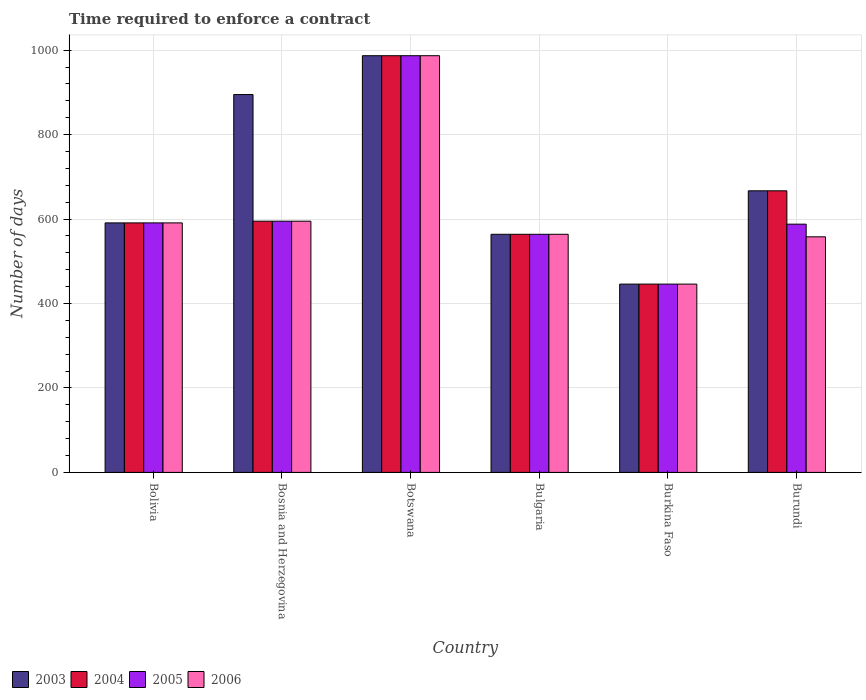How many different coloured bars are there?
Your response must be concise. 4. Are the number of bars per tick equal to the number of legend labels?
Provide a short and direct response. Yes. Are the number of bars on each tick of the X-axis equal?
Your response must be concise. Yes. How many bars are there on the 6th tick from the left?
Provide a succinct answer. 4. What is the number of days required to enforce a contract in 2005 in Botswana?
Keep it short and to the point. 987. Across all countries, what is the maximum number of days required to enforce a contract in 2004?
Your answer should be very brief. 987. Across all countries, what is the minimum number of days required to enforce a contract in 2005?
Provide a succinct answer. 446. In which country was the number of days required to enforce a contract in 2006 maximum?
Offer a terse response. Botswana. In which country was the number of days required to enforce a contract in 2006 minimum?
Provide a short and direct response. Burkina Faso. What is the total number of days required to enforce a contract in 2006 in the graph?
Keep it short and to the point. 3741. What is the difference between the number of days required to enforce a contract in 2005 in Bosnia and Herzegovina and that in Burkina Faso?
Offer a terse response. 149. What is the difference between the number of days required to enforce a contract in 2004 in Botswana and the number of days required to enforce a contract in 2003 in Bolivia?
Keep it short and to the point. 396. What is the average number of days required to enforce a contract in 2006 per country?
Your answer should be compact. 623.5. What is the ratio of the number of days required to enforce a contract in 2005 in Bolivia to that in Botswana?
Your answer should be compact. 0.6. Is the difference between the number of days required to enforce a contract in 2004 in Burkina Faso and Burundi greater than the difference between the number of days required to enforce a contract in 2003 in Burkina Faso and Burundi?
Offer a very short reply. No. What is the difference between the highest and the second highest number of days required to enforce a contract in 2005?
Your response must be concise. -392. What is the difference between the highest and the lowest number of days required to enforce a contract in 2004?
Your answer should be very brief. 541. In how many countries, is the number of days required to enforce a contract in 2004 greater than the average number of days required to enforce a contract in 2004 taken over all countries?
Your answer should be very brief. 2. Is it the case that in every country, the sum of the number of days required to enforce a contract in 2005 and number of days required to enforce a contract in 2004 is greater than the sum of number of days required to enforce a contract in 2006 and number of days required to enforce a contract in 2003?
Your answer should be compact. No. Is it the case that in every country, the sum of the number of days required to enforce a contract in 2004 and number of days required to enforce a contract in 2005 is greater than the number of days required to enforce a contract in 2006?
Your answer should be very brief. Yes. How many countries are there in the graph?
Offer a terse response. 6. Where does the legend appear in the graph?
Your response must be concise. Bottom left. How many legend labels are there?
Give a very brief answer. 4. What is the title of the graph?
Provide a short and direct response. Time required to enforce a contract. Does "2009" appear as one of the legend labels in the graph?
Offer a terse response. No. What is the label or title of the Y-axis?
Ensure brevity in your answer.  Number of days. What is the Number of days in 2003 in Bolivia?
Offer a very short reply. 591. What is the Number of days in 2004 in Bolivia?
Your response must be concise. 591. What is the Number of days of 2005 in Bolivia?
Provide a succinct answer. 591. What is the Number of days of 2006 in Bolivia?
Give a very brief answer. 591. What is the Number of days in 2003 in Bosnia and Herzegovina?
Your response must be concise. 895. What is the Number of days of 2004 in Bosnia and Herzegovina?
Keep it short and to the point. 595. What is the Number of days of 2005 in Bosnia and Herzegovina?
Provide a succinct answer. 595. What is the Number of days of 2006 in Bosnia and Herzegovina?
Offer a terse response. 595. What is the Number of days in 2003 in Botswana?
Ensure brevity in your answer.  987. What is the Number of days in 2004 in Botswana?
Keep it short and to the point. 987. What is the Number of days of 2005 in Botswana?
Provide a succinct answer. 987. What is the Number of days in 2006 in Botswana?
Make the answer very short. 987. What is the Number of days of 2003 in Bulgaria?
Offer a terse response. 564. What is the Number of days of 2004 in Bulgaria?
Offer a terse response. 564. What is the Number of days of 2005 in Bulgaria?
Provide a short and direct response. 564. What is the Number of days in 2006 in Bulgaria?
Your answer should be very brief. 564. What is the Number of days of 2003 in Burkina Faso?
Your response must be concise. 446. What is the Number of days in 2004 in Burkina Faso?
Provide a succinct answer. 446. What is the Number of days of 2005 in Burkina Faso?
Provide a short and direct response. 446. What is the Number of days in 2006 in Burkina Faso?
Offer a terse response. 446. What is the Number of days in 2003 in Burundi?
Make the answer very short. 667. What is the Number of days of 2004 in Burundi?
Your response must be concise. 667. What is the Number of days of 2005 in Burundi?
Your answer should be very brief. 588. What is the Number of days of 2006 in Burundi?
Keep it short and to the point. 558. Across all countries, what is the maximum Number of days in 2003?
Ensure brevity in your answer.  987. Across all countries, what is the maximum Number of days in 2004?
Your answer should be very brief. 987. Across all countries, what is the maximum Number of days of 2005?
Offer a terse response. 987. Across all countries, what is the maximum Number of days of 2006?
Your answer should be compact. 987. Across all countries, what is the minimum Number of days of 2003?
Offer a very short reply. 446. Across all countries, what is the minimum Number of days in 2004?
Your answer should be very brief. 446. Across all countries, what is the minimum Number of days of 2005?
Offer a terse response. 446. Across all countries, what is the minimum Number of days in 2006?
Offer a terse response. 446. What is the total Number of days of 2003 in the graph?
Ensure brevity in your answer.  4150. What is the total Number of days in 2004 in the graph?
Ensure brevity in your answer.  3850. What is the total Number of days in 2005 in the graph?
Give a very brief answer. 3771. What is the total Number of days in 2006 in the graph?
Your response must be concise. 3741. What is the difference between the Number of days of 2003 in Bolivia and that in Bosnia and Herzegovina?
Keep it short and to the point. -304. What is the difference between the Number of days in 2003 in Bolivia and that in Botswana?
Keep it short and to the point. -396. What is the difference between the Number of days of 2004 in Bolivia and that in Botswana?
Your response must be concise. -396. What is the difference between the Number of days of 2005 in Bolivia and that in Botswana?
Offer a terse response. -396. What is the difference between the Number of days of 2006 in Bolivia and that in Botswana?
Your response must be concise. -396. What is the difference between the Number of days of 2003 in Bolivia and that in Bulgaria?
Offer a terse response. 27. What is the difference between the Number of days of 2005 in Bolivia and that in Bulgaria?
Your response must be concise. 27. What is the difference between the Number of days of 2006 in Bolivia and that in Bulgaria?
Keep it short and to the point. 27. What is the difference between the Number of days in 2003 in Bolivia and that in Burkina Faso?
Give a very brief answer. 145. What is the difference between the Number of days of 2004 in Bolivia and that in Burkina Faso?
Provide a short and direct response. 145. What is the difference between the Number of days in 2005 in Bolivia and that in Burkina Faso?
Give a very brief answer. 145. What is the difference between the Number of days in 2006 in Bolivia and that in Burkina Faso?
Give a very brief answer. 145. What is the difference between the Number of days in 2003 in Bolivia and that in Burundi?
Your response must be concise. -76. What is the difference between the Number of days in 2004 in Bolivia and that in Burundi?
Provide a short and direct response. -76. What is the difference between the Number of days of 2003 in Bosnia and Herzegovina and that in Botswana?
Give a very brief answer. -92. What is the difference between the Number of days of 2004 in Bosnia and Herzegovina and that in Botswana?
Offer a very short reply. -392. What is the difference between the Number of days in 2005 in Bosnia and Herzegovina and that in Botswana?
Your response must be concise. -392. What is the difference between the Number of days of 2006 in Bosnia and Herzegovina and that in Botswana?
Your response must be concise. -392. What is the difference between the Number of days in 2003 in Bosnia and Herzegovina and that in Bulgaria?
Make the answer very short. 331. What is the difference between the Number of days of 2004 in Bosnia and Herzegovina and that in Bulgaria?
Offer a terse response. 31. What is the difference between the Number of days of 2006 in Bosnia and Herzegovina and that in Bulgaria?
Keep it short and to the point. 31. What is the difference between the Number of days of 2003 in Bosnia and Herzegovina and that in Burkina Faso?
Provide a succinct answer. 449. What is the difference between the Number of days of 2004 in Bosnia and Herzegovina and that in Burkina Faso?
Keep it short and to the point. 149. What is the difference between the Number of days of 2005 in Bosnia and Herzegovina and that in Burkina Faso?
Offer a very short reply. 149. What is the difference between the Number of days of 2006 in Bosnia and Herzegovina and that in Burkina Faso?
Your answer should be very brief. 149. What is the difference between the Number of days in 2003 in Bosnia and Herzegovina and that in Burundi?
Your answer should be very brief. 228. What is the difference between the Number of days in 2004 in Bosnia and Herzegovina and that in Burundi?
Your answer should be very brief. -72. What is the difference between the Number of days of 2005 in Bosnia and Herzegovina and that in Burundi?
Make the answer very short. 7. What is the difference between the Number of days of 2006 in Bosnia and Herzegovina and that in Burundi?
Keep it short and to the point. 37. What is the difference between the Number of days of 2003 in Botswana and that in Bulgaria?
Keep it short and to the point. 423. What is the difference between the Number of days in 2004 in Botswana and that in Bulgaria?
Provide a short and direct response. 423. What is the difference between the Number of days in 2005 in Botswana and that in Bulgaria?
Make the answer very short. 423. What is the difference between the Number of days of 2006 in Botswana and that in Bulgaria?
Your answer should be very brief. 423. What is the difference between the Number of days of 2003 in Botswana and that in Burkina Faso?
Offer a very short reply. 541. What is the difference between the Number of days in 2004 in Botswana and that in Burkina Faso?
Offer a very short reply. 541. What is the difference between the Number of days of 2005 in Botswana and that in Burkina Faso?
Offer a very short reply. 541. What is the difference between the Number of days of 2006 in Botswana and that in Burkina Faso?
Keep it short and to the point. 541. What is the difference between the Number of days of 2003 in Botswana and that in Burundi?
Make the answer very short. 320. What is the difference between the Number of days in 2004 in Botswana and that in Burundi?
Offer a terse response. 320. What is the difference between the Number of days of 2005 in Botswana and that in Burundi?
Ensure brevity in your answer.  399. What is the difference between the Number of days in 2006 in Botswana and that in Burundi?
Keep it short and to the point. 429. What is the difference between the Number of days of 2003 in Bulgaria and that in Burkina Faso?
Give a very brief answer. 118. What is the difference between the Number of days in 2004 in Bulgaria and that in Burkina Faso?
Your answer should be very brief. 118. What is the difference between the Number of days in 2005 in Bulgaria and that in Burkina Faso?
Give a very brief answer. 118. What is the difference between the Number of days in 2006 in Bulgaria and that in Burkina Faso?
Provide a short and direct response. 118. What is the difference between the Number of days of 2003 in Bulgaria and that in Burundi?
Make the answer very short. -103. What is the difference between the Number of days of 2004 in Bulgaria and that in Burundi?
Your answer should be compact. -103. What is the difference between the Number of days in 2005 in Bulgaria and that in Burundi?
Your response must be concise. -24. What is the difference between the Number of days in 2006 in Bulgaria and that in Burundi?
Offer a very short reply. 6. What is the difference between the Number of days of 2003 in Burkina Faso and that in Burundi?
Ensure brevity in your answer.  -221. What is the difference between the Number of days of 2004 in Burkina Faso and that in Burundi?
Provide a short and direct response. -221. What is the difference between the Number of days in 2005 in Burkina Faso and that in Burundi?
Offer a very short reply. -142. What is the difference between the Number of days of 2006 in Burkina Faso and that in Burundi?
Give a very brief answer. -112. What is the difference between the Number of days of 2003 in Bolivia and the Number of days of 2004 in Bosnia and Herzegovina?
Provide a succinct answer. -4. What is the difference between the Number of days in 2003 in Bolivia and the Number of days in 2006 in Bosnia and Herzegovina?
Make the answer very short. -4. What is the difference between the Number of days in 2004 in Bolivia and the Number of days in 2005 in Bosnia and Herzegovina?
Your response must be concise. -4. What is the difference between the Number of days in 2004 in Bolivia and the Number of days in 2006 in Bosnia and Herzegovina?
Your answer should be compact. -4. What is the difference between the Number of days of 2003 in Bolivia and the Number of days of 2004 in Botswana?
Offer a terse response. -396. What is the difference between the Number of days in 2003 in Bolivia and the Number of days in 2005 in Botswana?
Ensure brevity in your answer.  -396. What is the difference between the Number of days in 2003 in Bolivia and the Number of days in 2006 in Botswana?
Provide a short and direct response. -396. What is the difference between the Number of days in 2004 in Bolivia and the Number of days in 2005 in Botswana?
Keep it short and to the point. -396. What is the difference between the Number of days of 2004 in Bolivia and the Number of days of 2006 in Botswana?
Make the answer very short. -396. What is the difference between the Number of days in 2005 in Bolivia and the Number of days in 2006 in Botswana?
Offer a terse response. -396. What is the difference between the Number of days in 2003 in Bolivia and the Number of days in 2005 in Bulgaria?
Provide a succinct answer. 27. What is the difference between the Number of days of 2003 in Bolivia and the Number of days of 2006 in Bulgaria?
Keep it short and to the point. 27. What is the difference between the Number of days in 2004 in Bolivia and the Number of days in 2006 in Bulgaria?
Ensure brevity in your answer.  27. What is the difference between the Number of days in 2003 in Bolivia and the Number of days in 2004 in Burkina Faso?
Provide a succinct answer. 145. What is the difference between the Number of days of 2003 in Bolivia and the Number of days of 2005 in Burkina Faso?
Your answer should be very brief. 145. What is the difference between the Number of days of 2003 in Bolivia and the Number of days of 2006 in Burkina Faso?
Offer a terse response. 145. What is the difference between the Number of days of 2004 in Bolivia and the Number of days of 2005 in Burkina Faso?
Ensure brevity in your answer.  145. What is the difference between the Number of days of 2004 in Bolivia and the Number of days of 2006 in Burkina Faso?
Provide a short and direct response. 145. What is the difference between the Number of days of 2005 in Bolivia and the Number of days of 2006 in Burkina Faso?
Provide a succinct answer. 145. What is the difference between the Number of days of 2003 in Bolivia and the Number of days of 2004 in Burundi?
Your answer should be compact. -76. What is the difference between the Number of days in 2003 in Bolivia and the Number of days in 2005 in Burundi?
Give a very brief answer. 3. What is the difference between the Number of days of 2004 in Bolivia and the Number of days of 2006 in Burundi?
Give a very brief answer. 33. What is the difference between the Number of days in 2003 in Bosnia and Herzegovina and the Number of days in 2004 in Botswana?
Provide a short and direct response. -92. What is the difference between the Number of days in 2003 in Bosnia and Herzegovina and the Number of days in 2005 in Botswana?
Your answer should be very brief. -92. What is the difference between the Number of days in 2003 in Bosnia and Herzegovina and the Number of days in 2006 in Botswana?
Provide a succinct answer. -92. What is the difference between the Number of days of 2004 in Bosnia and Herzegovina and the Number of days of 2005 in Botswana?
Ensure brevity in your answer.  -392. What is the difference between the Number of days of 2004 in Bosnia and Herzegovina and the Number of days of 2006 in Botswana?
Keep it short and to the point. -392. What is the difference between the Number of days in 2005 in Bosnia and Herzegovina and the Number of days in 2006 in Botswana?
Offer a very short reply. -392. What is the difference between the Number of days in 2003 in Bosnia and Herzegovina and the Number of days in 2004 in Bulgaria?
Give a very brief answer. 331. What is the difference between the Number of days of 2003 in Bosnia and Herzegovina and the Number of days of 2005 in Bulgaria?
Offer a terse response. 331. What is the difference between the Number of days in 2003 in Bosnia and Herzegovina and the Number of days in 2006 in Bulgaria?
Offer a very short reply. 331. What is the difference between the Number of days of 2004 in Bosnia and Herzegovina and the Number of days of 2005 in Bulgaria?
Your answer should be very brief. 31. What is the difference between the Number of days in 2005 in Bosnia and Herzegovina and the Number of days in 2006 in Bulgaria?
Offer a very short reply. 31. What is the difference between the Number of days in 2003 in Bosnia and Herzegovina and the Number of days in 2004 in Burkina Faso?
Keep it short and to the point. 449. What is the difference between the Number of days in 2003 in Bosnia and Herzegovina and the Number of days in 2005 in Burkina Faso?
Give a very brief answer. 449. What is the difference between the Number of days in 2003 in Bosnia and Herzegovina and the Number of days in 2006 in Burkina Faso?
Keep it short and to the point. 449. What is the difference between the Number of days in 2004 in Bosnia and Herzegovina and the Number of days in 2005 in Burkina Faso?
Your answer should be very brief. 149. What is the difference between the Number of days of 2004 in Bosnia and Herzegovina and the Number of days of 2006 in Burkina Faso?
Keep it short and to the point. 149. What is the difference between the Number of days in 2005 in Bosnia and Herzegovina and the Number of days in 2006 in Burkina Faso?
Provide a succinct answer. 149. What is the difference between the Number of days in 2003 in Bosnia and Herzegovina and the Number of days in 2004 in Burundi?
Make the answer very short. 228. What is the difference between the Number of days of 2003 in Bosnia and Herzegovina and the Number of days of 2005 in Burundi?
Make the answer very short. 307. What is the difference between the Number of days of 2003 in Bosnia and Herzegovina and the Number of days of 2006 in Burundi?
Provide a succinct answer. 337. What is the difference between the Number of days of 2005 in Bosnia and Herzegovina and the Number of days of 2006 in Burundi?
Your answer should be compact. 37. What is the difference between the Number of days of 2003 in Botswana and the Number of days of 2004 in Bulgaria?
Ensure brevity in your answer.  423. What is the difference between the Number of days of 2003 in Botswana and the Number of days of 2005 in Bulgaria?
Your answer should be very brief. 423. What is the difference between the Number of days in 2003 in Botswana and the Number of days in 2006 in Bulgaria?
Provide a short and direct response. 423. What is the difference between the Number of days of 2004 in Botswana and the Number of days of 2005 in Bulgaria?
Ensure brevity in your answer.  423. What is the difference between the Number of days of 2004 in Botswana and the Number of days of 2006 in Bulgaria?
Your answer should be compact. 423. What is the difference between the Number of days in 2005 in Botswana and the Number of days in 2006 in Bulgaria?
Ensure brevity in your answer.  423. What is the difference between the Number of days in 2003 in Botswana and the Number of days in 2004 in Burkina Faso?
Your answer should be very brief. 541. What is the difference between the Number of days of 2003 in Botswana and the Number of days of 2005 in Burkina Faso?
Provide a succinct answer. 541. What is the difference between the Number of days in 2003 in Botswana and the Number of days in 2006 in Burkina Faso?
Provide a short and direct response. 541. What is the difference between the Number of days in 2004 in Botswana and the Number of days in 2005 in Burkina Faso?
Provide a short and direct response. 541. What is the difference between the Number of days in 2004 in Botswana and the Number of days in 2006 in Burkina Faso?
Give a very brief answer. 541. What is the difference between the Number of days of 2005 in Botswana and the Number of days of 2006 in Burkina Faso?
Provide a short and direct response. 541. What is the difference between the Number of days of 2003 in Botswana and the Number of days of 2004 in Burundi?
Give a very brief answer. 320. What is the difference between the Number of days in 2003 in Botswana and the Number of days in 2005 in Burundi?
Provide a succinct answer. 399. What is the difference between the Number of days of 2003 in Botswana and the Number of days of 2006 in Burundi?
Provide a short and direct response. 429. What is the difference between the Number of days of 2004 in Botswana and the Number of days of 2005 in Burundi?
Keep it short and to the point. 399. What is the difference between the Number of days in 2004 in Botswana and the Number of days in 2006 in Burundi?
Keep it short and to the point. 429. What is the difference between the Number of days of 2005 in Botswana and the Number of days of 2006 in Burundi?
Your response must be concise. 429. What is the difference between the Number of days in 2003 in Bulgaria and the Number of days in 2004 in Burkina Faso?
Make the answer very short. 118. What is the difference between the Number of days of 2003 in Bulgaria and the Number of days of 2005 in Burkina Faso?
Make the answer very short. 118. What is the difference between the Number of days in 2003 in Bulgaria and the Number of days in 2006 in Burkina Faso?
Ensure brevity in your answer.  118. What is the difference between the Number of days of 2004 in Bulgaria and the Number of days of 2005 in Burkina Faso?
Ensure brevity in your answer.  118. What is the difference between the Number of days in 2004 in Bulgaria and the Number of days in 2006 in Burkina Faso?
Ensure brevity in your answer.  118. What is the difference between the Number of days in 2005 in Bulgaria and the Number of days in 2006 in Burkina Faso?
Your answer should be compact. 118. What is the difference between the Number of days of 2003 in Bulgaria and the Number of days of 2004 in Burundi?
Offer a very short reply. -103. What is the difference between the Number of days of 2003 in Bulgaria and the Number of days of 2006 in Burundi?
Provide a short and direct response. 6. What is the difference between the Number of days in 2003 in Burkina Faso and the Number of days in 2004 in Burundi?
Make the answer very short. -221. What is the difference between the Number of days in 2003 in Burkina Faso and the Number of days in 2005 in Burundi?
Your response must be concise. -142. What is the difference between the Number of days in 2003 in Burkina Faso and the Number of days in 2006 in Burundi?
Your response must be concise. -112. What is the difference between the Number of days in 2004 in Burkina Faso and the Number of days in 2005 in Burundi?
Ensure brevity in your answer.  -142. What is the difference between the Number of days in 2004 in Burkina Faso and the Number of days in 2006 in Burundi?
Your answer should be very brief. -112. What is the difference between the Number of days in 2005 in Burkina Faso and the Number of days in 2006 in Burundi?
Your response must be concise. -112. What is the average Number of days in 2003 per country?
Provide a short and direct response. 691.67. What is the average Number of days in 2004 per country?
Offer a terse response. 641.67. What is the average Number of days of 2005 per country?
Your answer should be very brief. 628.5. What is the average Number of days of 2006 per country?
Make the answer very short. 623.5. What is the difference between the Number of days of 2003 and Number of days of 2004 in Bolivia?
Your answer should be compact. 0. What is the difference between the Number of days of 2004 and Number of days of 2005 in Bolivia?
Keep it short and to the point. 0. What is the difference between the Number of days in 2003 and Number of days in 2004 in Bosnia and Herzegovina?
Your answer should be compact. 300. What is the difference between the Number of days in 2003 and Number of days in 2005 in Bosnia and Herzegovina?
Your answer should be very brief. 300. What is the difference between the Number of days in 2003 and Number of days in 2006 in Bosnia and Herzegovina?
Ensure brevity in your answer.  300. What is the difference between the Number of days of 2004 and Number of days of 2005 in Bosnia and Herzegovina?
Provide a succinct answer. 0. What is the difference between the Number of days of 2003 and Number of days of 2006 in Botswana?
Your answer should be compact. 0. What is the difference between the Number of days of 2004 and Number of days of 2006 in Botswana?
Provide a succinct answer. 0. What is the difference between the Number of days of 2003 and Number of days of 2004 in Bulgaria?
Provide a short and direct response. 0. What is the difference between the Number of days in 2003 and Number of days in 2005 in Bulgaria?
Offer a terse response. 0. What is the difference between the Number of days in 2003 and Number of days in 2006 in Bulgaria?
Give a very brief answer. 0. What is the difference between the Number of days in 2004 and Number of days in 2005 in Bulgaria?
Your answer should be very brief. 0. What is the difference between the Number of days of 2004 and Number of days of 2005 in Burkina Faso?
Your response must be concise. 0. What is the difference between the Number of days in 2003 and Number of days in 2005 in Burundi?
Offer a very short reply. 79. What is the difference between the Number of days of 2003 and Number of days of 2006 in Burundi?
Provide a short and direct response. 109. What is the difference between the Number of days in 2004 and Number of days in 2005 in Burundi?
Keep it short and to the point. 79. What is the difference between the Number of days in 2004 and Number of days in 2006 in Burundi?
Your response must be concise. 109. What is the ratio of the Number of days in 2003 in Bolivia to that in Bosnia and Herzegovina?
Offer a terse response. 0.66. What is the ratio of the Number of days of 2005 in Bolivia to that in Bosnia and Herzegovina?
Offer a terse response. 0.99. What is the ratio of the Number of days in 2006 in Bolivia to that in Bosnia and Herzegovina?
Your answer should be compact. 0.99. What is the ratio of the Number of days in 2003 in Bolivia to that in Botswana?
Keep it short and to the point. 0.6. What is the ratio of the Number of days of 2004 in Bolivia to that in Botswana?
Provide a short and direct response. 0.6. What is the ratio of the Number of days of 2005 in Bolivia to that in Botswana?
Your response must be concise. 0.6. What is the ratio of the Number of days of 2006 in Bolivia to that in Botswana?
Ensure brevity in your answer.  0.6. What is the ratio of the Number of days of 2003 in Bolivia to that in Bulgaria?
Provide a short and direct response. 1.05. What is the ratio of the Number of days of 2004 in Bolivia to that in Bulgaria?
Offer a terse response. 1.05. What is the ratio of the Number of days of 2005 in Bolivia to that in Bulgaria?
Ensure brevity in your answer.  1.05. What is the ratio of the Number of days in 2006 in Bolivia to that in Bulgaria?
Make the answer very short. 1.05. What is the ratio of the Number of days of 2003 in Bolivia to that in Burkina Faso?
Ensure brevity in your answer.  1.33. What is the ratio of the Number of days in 2004 in Bolivia to that in Burkina Faso?
Your response must be concise. 1.33. What is the ratio of the Number of days in 2005 in Bolivia to that in Burkina Faso?
Make the answer very short. 1.33. What is the ratio of the Number of days in 2006 in Bolivia to that in Burkina Faso?
Make the answer very short. 1.33. What is the ratio of the Number of days of 2003 in Bolivia to that in Burundi?
Your answer should be compact. 0.89. What is the ratio of the Number of days in 2004 in Bolivia to that in Burundi?
Keep it short and to the point. 0.89. What is the ratio of the Number of days of 2006 in Bolivia to that in Burundi?
Offer a terse response. 1.06. What is the ratio of the Number of days in 2003 in Bosnia and Herzegovina to that in Botswana?
Make the answer very short. 0.91. What is the ratio of the Number of days of 2004 in Bosnia and Herzegovina to that in Botswana?
Provide a short and direct response. 0.6. What is the ratio of the Number of days in 2005 in Bosnia and Herzegovina to that in Botswana?
Offer a very short reply. 0.6. What is the ratio of the Number of days in 2006 in Bosnia and Herzegovina to that in Botswana?
Offer a very short reply. 0.6. What is the ratio of the Number of days of 2003 in Bosnia and Herzegovina to that in Bulgaria?
Make the answer very short. 1.59. What is the ratio of the Number of days in 2004 in Bosnia and Herzegovina to that in Bulgaria?
Your answer should be compact. 1.05. What is the ratio of the Number of days of 2005 in Bosnia and Herzegovina to that in Bulgaria?
Offer a terse response. 1.05. What is the ratio of the Number of days of 2006 in Bosnia and Herzegovina to that in Bulgaria?
Ensure brevity in your answer.  1.05. What is the ratio of the Number of days in 2003 in Bosnia and Herzegovina to that in Burkina Faso?
Provide a succinct answer. 2.01. What is the ratio of the Number of days of 2004 in Bosnia and Herzegovina to that in Burkina Faso?
Provide a succinct answer. 1.33. What is the ratio of the Number of days in 2005 in Bosnia and Herzegovina to that in Burkina Faso?
Ensure brevity in your answer.  1.33. What is the ratio of the Number of days in 2006 in Bosnia and Herzegovina to that in Burkina Faso?
Keep it short and to the point. 1.33. What is the ratio of the Number of days of 2003 in Bosnia and Herzegovina to that in Burundi?
Make the answer very short. 1.34. What is the ratio of the Number of days in 2004 in Bosnia and Herzegovina to that in Burundi?
Provide a succinct answer. 0.89. What is the ratio of the Number of days in 2005 in Bosnia and Herzegovina to that in Burundi?
Your answer should be compact. 1.01. What is the ratio of the Number of days of 2006 in Bosnia and Herzegovina to that in Burundi?
Offer a terse response. 1.07. What is the ratio of the Number of days of 2003 in Botswana to that in Burkina Faso?
Your answer should be very brief. 2.21. What is the ratio of the Number of days of 2004 in Botswana to that in Burkina Faso?
Provide a short and direct response. 2.21. What is the ratio of the Number of days in 2005 in Botswana to that in Burkina Faso?
Your response must be concise. 2.21. What is the ratio of the Number of days of 2006 in Botswana to that in Burkina Faso?
Keep it short and to the point. 2.21. What is the ratio of the Number of days of 2003 in Botswana to that in Burundi?
Offer a very short reply. 1.48. What is the ratio of the Number of days of 2004 in Botswana to that in Burundi?
Your response must be concise. 1.48. What is the ratio of the Number of days in 2005 in Botswana to that in Burundi?
Offer a very short reply. 1.68. What is the ratio of the Number of days in 2006 in Botswana to that in Burundi?
Offer a very short reply. 1.77. What is the ratio of the Number of days in 2003 in Bulgaria to that in Burkina Faso?
Your answer should be very brief. 1.26. What is the ratio of the Number of days of 2004 in Bulgaria to that in Burkina Faso?
Offer a very short reply. 1.26. What is the ratio of the Number of days of 2005 in Bulgaria to that in Burkina Faso?
Provide a short and direct response. 1.26. What is the ratio of the Number of days of 2006 in Bulgaria to that in Burkina Faso?
Give a very brief answer. 1.26. What is the ratio of the Number of days of 2003 in Bulgaria to that in Burundi?
Your answer should be compact. 0.85. What is the ratio of the Number of days in 2004 in Bulgaria to that in Burundi?
Your answer should be very brief. 0.85. What is the ratio of the Number of days of 2005 in Bulgaria to that in Burundi?
Offer a terse response. 0.96. What is the ratio of the Number of days in 2006 in Bulgaria to that in Burundi?
Provide a short and direct response. 1.01. What is the ratio of the Number of days in 2003 in Burkina Faso to that in Burundi?
Make the answer very short. 0.67. What is the ratio of the Number of days of 2004 in Burkina Faso to that in Burundi?
Make the answer very short. 0.67. What is the ratio of the Number of days of 2005 in Burkina Faso to that in Burundi?
Ensure brevity in your answer.  0.76. What is the ratio of the Number of days in 2006 in Burkina Faso to that in Burundi?
Offer a very short reply. 0.8. What is the difference between the highest and the second highest Number of days in 2003?
Keep it short and to the point. 92. What is the difference between the highest and the second highest Number of days in 2004?
Provide a short and direct response. 320. What is the difference between the highest and the second highest Number of days of 2005?
Offer a very short reply. 392. What is the difference between the highest and the second highest Number of days in 2006?
Your response must be concise. 392. What is the difference between the highest and the lowest Number of days in 2003?
Provide a succinct answer. 541. What is the difference between the highest and the lowest Number of days of 2004?
Keep it short and to the point. 541. What is the difference between the highest and the lowest Number of days in 2005?
Offer a very short reply. 541. What is the difference between the highest and the lowest Number of days in 2006?
Offer a very short reply. 541. 